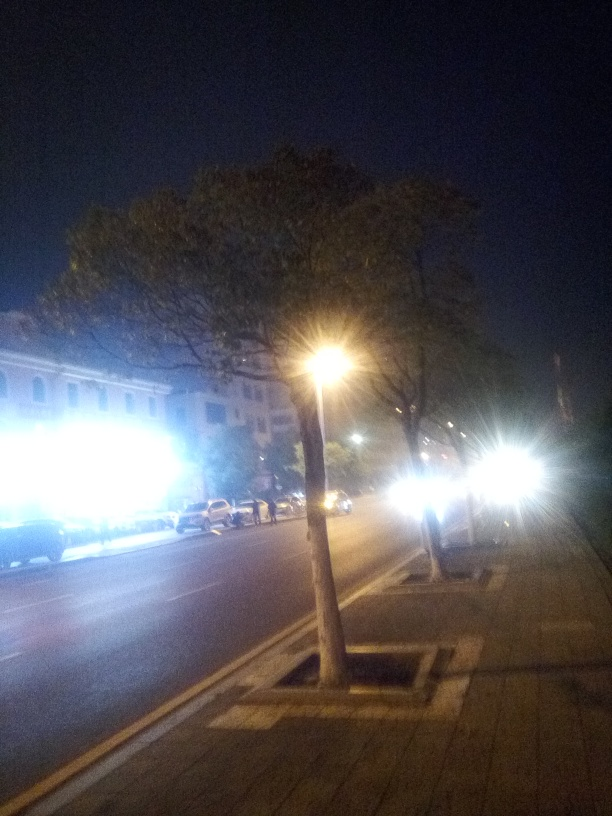What time of day does this image look like it was taken? Based on the low light levels and the artificial lighting seen in the streetlamps and vehicle headlights, this image appears to have been taken during nighttime. 